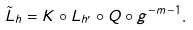<formula> <loc_0><loc_0><loc_500><loc_500>\tilde { L } _ { h } = K \circ L _ { h ^ { \prime } } \circ Q \circ g ^ { - m - 1 } .</formula> 